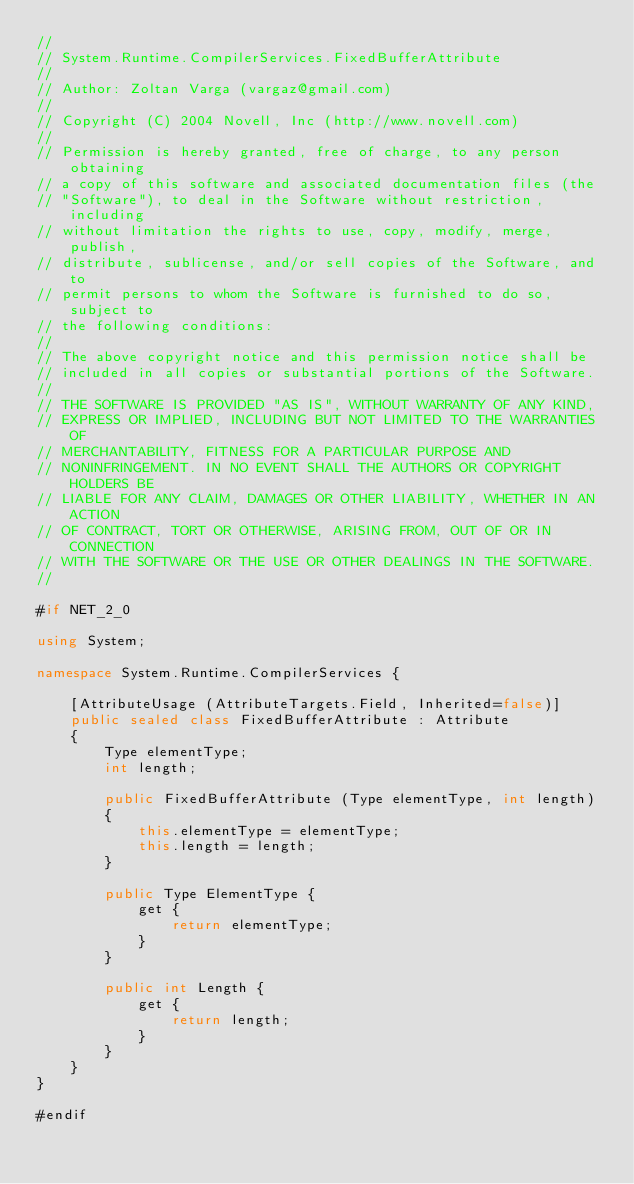<code> <loc_0><loc_0><loc_500><loc_500><_C#_>//
// System.Runtime.CompilerServices.FixedBufferAttribute
//
// Author: Zoltan Varga (vargaz@gmail.com)
//
// Copyright (C) 2004 Novell, Inc (http://www.novell.com)
//
// Permission is hereby granted, free of charge, to any person obtaining
// a copy of this software and associated documentation files (the
// "Software"), to deal in the Software without restriction, including
// without limitation the rights to use, copy, modify, merge, publish,
// distribute, sublicense, and/or sell copies of the Software, and to
// permit persons to whom the Software is furnished to do so, subject to
// the following conditions:
// 
// The above copyright notice and this permission notice shall be
// included in all copies or substantial portions of the Software.
// 
// THE SOFTWARE IS PROVIDED "AS IS", WITHOUT WARRANTY OF ANY KIND,
// EXPRESS OR IMPLIED, INCLUDING BUT NOT LIMITED TO THE WARRANTIES OF
// MERCHANTABILITY, FITNESS FOR A PARTICULAR PURPOSE AND
// NONINFRINGEMENT. IN NO EVENT SHALL THE AUTHORS OR COPYRIGHT HOLDERS BE
// LIABLE FOR ANY CLAIM, DAMAGES OR OTHER LIABILITY, WHETHER IN AN ACTION
// OF CONTRACT, TORT OR OTHERWISE, ARISING FROM, OUT OF OR IN CONNECTION
// WITH THE SOFTWARE OR THE USE OR OTHER DEALINGS IN THE SOFTWARE.
//

#if NET_2_0

using System;

namespace System.Runtime.CompilerServices {

	[AttributeUsage (AttributeTargets.Field, Inherited=false)] 
	public sealed class FixedBufferAttribute : Attribute
	{
		Type elementType;
		int length;

		public FixedBufferAttribute (Type elementType, int length)
		{
			this.elementType = elementType;
			this.length = length;
		}

		public Type ElementType {
			get {
				return elementType;
			}
		}

		public int Length {
			get {
				return length;
			}
		}
	}
}

#endif
</code> 